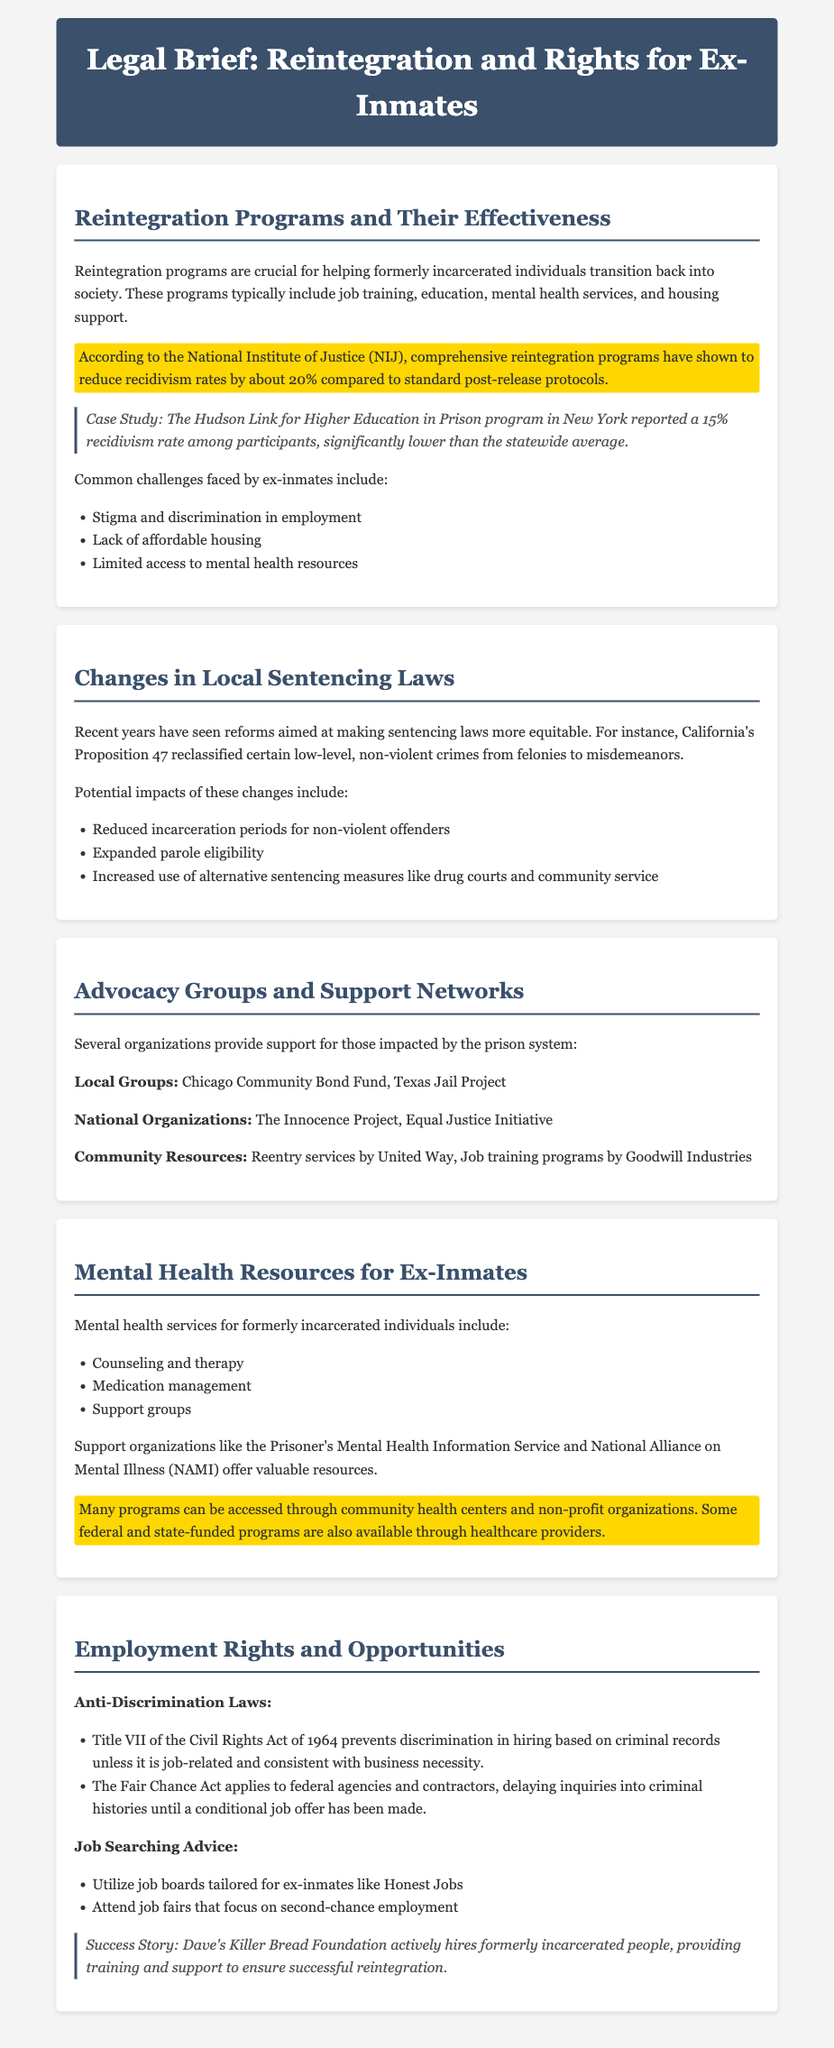What percentage reduction in recidivism rates do comprehensive reintegration programs achieve? The document states that comprehensive reintegration programs reduce recidivism rates by about 20% compared to standard post-release protocols.
Answer: 20% What case study is mentioned regarding recidivism rates in New York? The case study highlighted is the Hudson Link for Higher Education in Prison program in New York, which reported a 15% recidivism rate among participants.
Answer: Hudson Link for Higher Education in Prison What significant change did California's Proposition 47 introduce? Proposition 47 reclassified certain low-level, non-violent crimes from felonies to misdemeanors.
Answer: Reclassification of crimes Which two local advocacy groups are mentioned? The document lists the Chicago Community Bond Fund and Texas Jail Project as local advocacy groups.
Answer: Chicago Community Bond Fund, Texas Jail Project What type of services do Mental Health Resources for Ex-Inmates include? The mental health resources include counseling and therapy, medication management, and support groups.
Answer: Counseling and therapy, medication management, support groups What federal act delays inquiries into criminal histories until a job offer is made? The Fair Chance Act delays inquiries into criminal histories until a conditional job offer has been made.
Answer: Fair Chance Act What is a success story mentioned for employment opportunities for ex-inmates? The Dave's Killer Bread Foundation is mentioned as a success story for actively hiring formerly incarcerated people.
Answer: Dave's Killer Bread Foundation What is a common challenge faced by ex-inmates upon reintegration? Common challenges include stigma and discrimination in employment, lack of affordable housing, and limited access to mental health resources.
Answer: Stigma and discrimination in employment What organization provides support for mental health specifically for ex-inmates? The National Alliance on Mental Illness (NAMI) offers valuable resources for mental health support for ex-inmates.
Answer: NAMI 